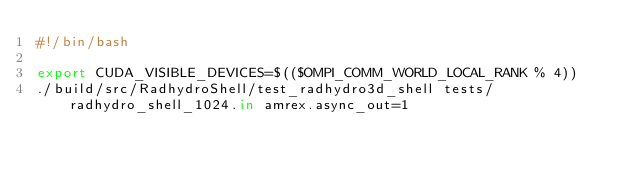Convert code to text. <code><loc_0><loc_0><loc_500><loc_500><_Bash_>#!/bin/bash

export CUDA_VISIBLE_DEVICES=$(($OMPI_COMM_WORLD_LOCAL_RANK % 4))
./build/src/RadhydroShell/test_radhydro3d_shell tests/radhydro_shell_1024.in amrex.async_out=1
</code> 